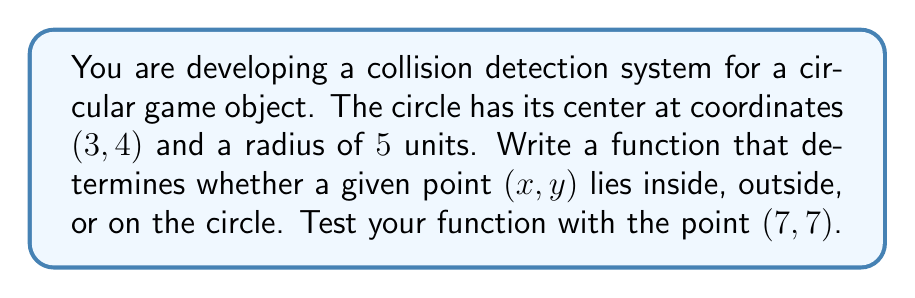Teach me how to tackle this problem. To solve this problem, we can use the equation of a circle and the distance formula. Here's a step-by-step approach:

1. The equation of a circle with center $(h, k)$ and radius $r$ is:

   $$(x - h)^2 + (y - k)^2 = r^2$$

2. In this case, $h = 3$, $k = 4$, and $r = 5$. Substituting these values:

   $$(x - 3)^2 + (y - 4)^2 = 5^2 = 25$$

3. To determine if a point $(x, y)$ is inside, outside, or on the circle, we calculate the left side of the equation and compare it to $25$:

   - If $(x - 3)^2 + (y - 4)^2 < 25$, the point is inside the circle
   - If $(x - 3)^2 + (y - 4)^2 > 25$, the point is outside the circle
   - If $(x - 3)^2 + (y - 4)^2 = 25$, the point is on the circle

4. Let's test the point (7, 7):

   $(7 - 3)^2 + (7 - 4)^2 = 4^2 + 3^2 = 16 + 9 = 25$

5. Since the result is exactly 25, the point (7, 7) lies on the circle.

Here's a Python function that implements this logic:

```python
def point_position(x, y):
    distance_squared = (x - 3)**2 + (y - 4)**2
    if distance_squared < 25:
        return "inside"
    elif distance_squared > 25:
        return "outside"
    else:
        return "on"

print(point_position(7, 7))  # Output: "on"
```

This function can be easily integrated into your collision detection system.

[asy]
import geometry;

draw(circle((3,4),5), blue);
dot((3,4), red);
dot((7,7), green);
label("(3,4)", (3,4), SE);
label("(7,7)", (7,7), NE);
draw((3,4)--(7,7), dashed);
label("r=5", (5.5,4), N);
xaxis(-2,10,Arrow);
yaxis(-2,10,Arrow);
[/asy]
Answer: The point (7, 7) lies on the circle. 